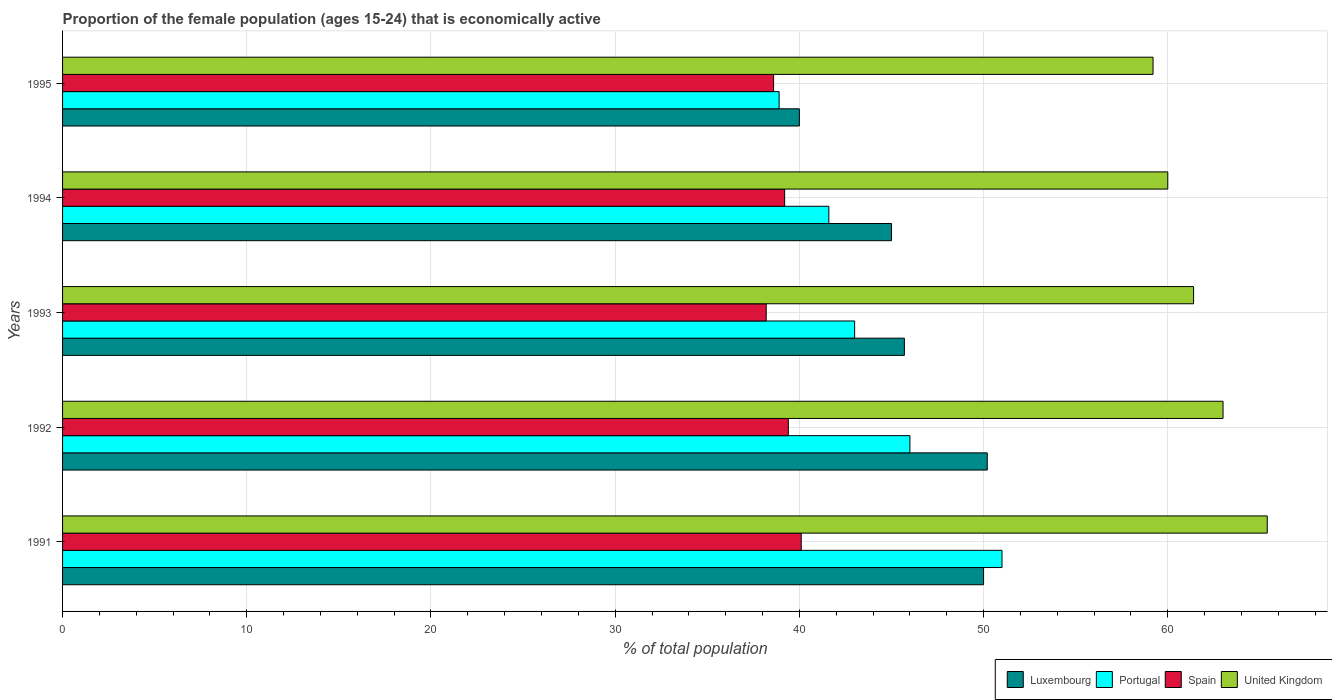How many different coloured bars are there?
Your answer should be very brief. 4. What is the label of the 1st group of bars from the top?
Your answer should be very brief. 1995. In how many cases, is the number of bars for a given year not equal to the number of legend labels?
Provide a short and direct response. 0. Across all years, what is the maximum proportion of the female population that is economically active in United Kingdom?
Your answer should be very brief. 65.4. Across all years, what is the minimum proportion of the female population that is economically active in Portugal?
Ensure brevity in your answer.  38.9. What is the total proportion of the female population that is economically active in Luxembourg in the graph?
Make the answer very short. 230.9. What is the difference between the proportion of the female population that is economically active in United Kingdom in 1991 and that in 1993?
Provide a succinct answer. 4. What is the difference between the proportion of the female population that is economically active in Portugal in 1992 and the proportion of the female population that is economically active in Luxembourg in 1993?
Your answer should be very brief. 0.3. What is the average proportion of the female population that is economically active in Luxembourg per year?
Offer a very short reply. 46.18. In the year 1992, what is the difference between the proportion of the female population that is economically active in Spain and proportion of the female population that is economically active in Portugal?
Your answer should be very brief. -6.6. What is the ratio of the proportion of the female population that is economically active in United Kingdom in 1991 to that in 1993?
Give a very brief answer. 1.07. Is the proportion of the female population that is economically active in Spain in 1991 less than that in 1992?
Your answer should be compact. No. Is the difference between the proportion of the female population that is economically active in Spain in 1991 and 1995 greater than the difference between the proportion of the female population that is economically active in Portugal in 1991 and 1995?
Offer a very short reply. No. What is the difference between the highest and the second highest proportion of the female population that is economically active in Spain?
Make the answer very short. 0.7. What is the difference between the highest and the lowest proportion of the female population that is economically active in Spain?
Give a very brief answer. 1.9. In how many years, is the proportion of the female population that is economically active in Portugal greater than the average proportion of the female population that is economically active in Portugal taken over all years?
Offer a terse response. 2. Is it the case that in every year, the sum of the proportion of the female population that is economically active in Luxembourg and proportion of the female population that is economically active in Spain is greater than the sum of proportion of the female population that is economically active in Portugal and proportion of the female population that is economically active in United Kingdom?
Keep it short and to the point. No. What does the 1st bar from the bottom in 1995 represents?
Offer a very short reply. Luxembourg. Is it the case that in every year, the sum of the proportion of the female population that is economically active in Portugal and proportion of the female population that is economically active in Spain is greater than the proportion of the female population that is economically active in United Kingdom?
Your response must be concise. Yes. How many years are there in the graph?
Offer a very short reply. 5. What is the difference between two consecutive major ticks on the X-axis?
Provide a short and direct response. 10. How many legend labels are there?
Offer a terse response. 4. How are the legend labels stacked?
Keep it short and to the point. Horizontal. What is the title of the graph?
Provide a short and direct response. Proportion of the female population (ages 15-24) that is economically active. Does "Croatia" appear as one of the legend labels in the graph?
Give a very brief answer. No. What is the label or title of the X-axis?
Offer a terse response. % of total population. What is the % of total population of Luxembourg in 1991?
Offer a terse response. 50. What is the % of total population of Portugal in 1991?
Your answer should be very brief. 51. What is the % of total population in Spain in 1991?
Give a very brief answer. 40.1. What is the % of total population of United Kingdom in 1991?
Offer a terse response. 65.4. What is the % of total population in Luxembourg in 1992?
Ensure brevity in your answer.  50.2. What is the % of total population in Portugal in 1992?
Provide a short and direct response. 46. What is the % of total population in Spain in 1992?
Make the answer very short. 39.4. What is the % of total population of United Kingdom in 1992?
Offer a very short reply. 63. What is the % of total population in Luxembourg in 1993?
Ensure brevity in your answer.  45.7. What is the % of total population in Portugal in 1993?
Ensure brevity in your answer.  43. What is the % of total population of Spain in 1993?
Offer a terse response. 38.2. What is the % of total population of United Kingdom in 1993?
Make the answer very short. 61.4. What is the % of total population in Luxembourg in 1994?
Your answer should be very brief. 45. What is the % of total population in Portugal in 1994?
Your response must be concise. 41.6. What is the % of total population of Spain in 1994?
Your answer should be very brief. 39.2. What is the % of total population in Luxembourg in 1995?
Provide a short and direct response. 40. What is the % of total population in Portugal in 1995?
Make the answer very short. 38.9. What is the % of total population in Spain in 1995?
Offer a very short reply. 38.6. What is the % of total population in United Kingdom in 1995?
Give a very brief answer. 59.2. Across all years, what is the maximum % of total population in Luxembourg?
Make the answer very short. 50.2. Across all years, what is the maximum % of total population of Spain?
Keep it short and to the point. 40.1. Across all years, what is the maximum % of total population in United Kingdom?
Your answer should be compact. 65.4. Across all years, what is the minimum % of total population of Portugal?
Offer a terse response. 38.9. Across all years, what is the minimum % of total population of Spain?
Provide a succinct answer. 38.2. Across all years, what is the minimum % of total population of United Kingdom?
Keep it short and to the point. 59.2. What is the total % of total population in Luxembourg in the graph?
Provide a short and direct response. 230.9. What is the total % of total population in Portugal in the graph?
Ensure brevity in your answer.  220.5. What is the total % of total population of Spain in the graph?
Make the answer very short. 195.5. What is the total % of total population in United Kingdom in the graph?
Your response must be concise. 309. What is the difference between the % of total population in Luxembourg in 1991 and that in 1992?
Provide a succinct answer. -0.2. What is the difference between the % of total population in Portugal in 1991 and that in 1992?
Keep it short and to the point. 5. What is the difference between the % of total population in Portugal in 1991 and that in 1993?
Keep it short and to the point. 8. What is the difference between the % of total population of Luxembourg in 1991 and that in 1994?
Your answer should be compact. 5. What is the difference between the % of total population in Portugal in 1991 and that in 1994?
Make the answer very short. 9.4. What is the difference between the % of total population in Spain in 1991 and that in 1994?
Your answer should be compact. 0.9. What is the difference between the % of total population of United Kingdom in 1991 and that in 1994?
Keep it short and to the point. 5.4. What is the difference between the % of total population of United Kingdom in 1991 and that in 1995?
Provide a short and direct response. 6.2. What is the difference between the % of total population in Luxembourg in 1992 and that in 1993?
Provide a short and direct response. 4.5. What is the difference between the % of total population of Portugal in 1992 and that in 1993?
Offer a very short reply. 3. What is the difference between the % of total population in United Kingdom in 1992 and that in 1993?
Your response must be concise. 1.6. What is the difference between the % of total population in Spain in 1992 and that in 1994?
Give a very brief answer. 0.2. What is the difference between the % of total population of Portugal in 1992 and that in 1995?
Give a very brief answer. 7.1. What is the difference between the % of total population in United Kingdom in 1992 and that in 1995?
Provide a succinct answer. 3.8. What is the difference between the % of total population of Portugal in 1993 and that in 1994?
Keep it short and to the point. 1.4. What is the difference between the % of total population of Spain in 1993 and that in 1994?
Offer a very short reply. -1. What is the difference between the % of total population of United Kingdom in 1993 and that in 1994?
Your answer should be compact. 1.4. What is the difference between the % of total population of Luxembourg in 1993 and that in 1995?
Your answer should be compact. 5.7. What is the difference between the % of total population of Spain in 1993 and that in 1995?
Your answer should be compact. -0.4. What is the difference between the % of total population in United Kingdom in 1993 and that in 1995?
Your answer should be compact. 2.2. What is the difference between the % of total population in Luxembourg in 1994 and that in 1995?
Your answer should be very brief. 5. What is the difference between the % of total population in Portugal in 1994 and that in 1995?
Provide a succinct answer. 2.7. What is the difference between the % of total population in Portugal in 1991 and the % of total population in Spain in 1992?
Offer a terse response. 11.6. What is the difference between the % of total population of Spain in 1991 and the % of total population of United Kingdom in 1992?
Your answer should be very brief. -22.9. What is the difference between the % of total population of Luxembourg in 1991 and the % of total population of Portugal in 1993?
Provide a succinct answer. 7. What is the difference between the % of total population of Luxembourg in 1991 and the % of total population of Spain in 1993?
Your answer should be very brief. 11.8. What is the difference between the % of total population in Portugal in 1991 and the % of total population in Spain in 1993?
Keep it short and to the point. 12.8. What is the difference between the % of total population in Spain in 1991 and the % of total population in United Kingdom in 1993?
Provide a succinct answer. -21.3. What is the difference between the % of total population in Luxembourg in 1991 and the % of total population in Portugal in 1994?
Keep it short and to the point. 8.4. What is the difference between the % of total population of Luxembourg in 1991 and the % of total population of Spain in 1994?
Your answer should be very brief. 10.8. What is the difference between the % of total population in Luxembourg in 1991 and the % of total population in United Kingdom in 1994?
Your answer should be compact. -10. What is the difference between the % of total population of Portugal in 1991 and the % of total population of Spain in 1994?
Your answer should be very brief. 11.8. What is the difference between the % of total population in Spain in 1991 and the % of total population in United Kingdom in 1994?
Provide a succinct answer. -19.9. What is the difference between the % of total population of Luxembourg in 1991 and the % of total population of Spain in 1995?
Ensure brevity in your answer.  11.4. What is the difference between the % of total population of Portugal in 1991 and the % of total population of Spain in 1995?
Your response must be concise. 12.4. What is the difference between the % of total population in Spain in 1991 and the % of total population in United Kingdom in 1995?
Offer a very short reply. -19.1. What is the difference between the % of total population in Luxembourg in 1992 and the % of total population in Spain in 1993?
Offer a terse response. 12. What is the difference between the % of total population of Luxembourg in 1992 and the % of total population of United Kingdom in 1993?
Offer a terse response. -11.2. What is the difference between the % of total population of Portugal in 1992 and the % of total population of Spain in 1993?
Keep it short and to the point. 7.8. What is the difference between the % of total population of Portugal in 1992 and the % of total population of United Kingdom in 1993?
Your answer should be compact. -15.4. What is the difference between the % of total population of Luxembourg in 1992 and the % of total population of Spain in 1994?
Your answer should be compact. 11. What is the difference between the % of total population in Portugal in 1992 and the % of total population in Spain in 1994?
Provide a short and direct response. 6.8. What is the difference between the % of total population of Portugal in 1992 and the % of total population of United Kingdom in 1994?
Provide a succinct answer. -14. What is the difference between the % of total population in Spain in 1992 and the % of total population in United Kingdom in 1994?
Provide a short and direct response. -20.6. What is the difference between the % of total population of Luxembourg in 1992 and the % of total population of United Kingdom in 1995?
Ensure brevity in your answer.  -9. What is the difference between the % of total population in Portugal in 1992 and the % of total population in Spain in 1995?
Give a very brief answer. 7.4. What is the difference between the % of total population of Spain in 1992 and the % of total population of United Kingdom in 1995?
Ensure brevity in your answer.  -19.8. What is the difference between the % of total population of Luxembourg in 1993 and the % of total population of Spain in 1994?
Provide a short and direct response. 6.5. What is the difference between the % of total population of Luxembourg in 1993 and the % of total population of United Kingdom in 1994?
Provide a short and direct response. -14.3. What is the difference between the % of total population of Spain in 1993 and the % of total population of United Kingdom in 1994?
Keep it short and to the point. -21.8. What is the difference between the % of total population in Luxembourg in 1993 and the % of total population in Spain in 1995?
Provide a short and direct response. 7.1. What is the difference between the % of total population in Luxembourg in 1993 and the % of total population in United Kingdom in 1995?
Provide a short and direct response. -13.5. What is the difference between the % of total population of Portugal in 1993 and the % of total population of Spain in 1995?
Keep it short and to the point. 4.4. What is the difference between the % of total population in Portugal in 1993 and the % of total population in United Kingdom in 1995?
Your answer should be compact. -16.2. What is the difference between the % of total population in Spain in 1993 and the % of total population in United Kingdom in 1995?
Provide a succinct answer. -21. What is the difference between the % of total population in Luxembourg in 1994 and the % of total population in Portugal in 1995?
Give a very brief answer. 6.1. What is the difference between the % of total population in Portugal in 1994 and the % of total population in Spain in 1995?
Make the answer very short. 3. What is the difference between the % of total population of Portugal in 1994 and the % of total population of United Kingdom in 1995?
Offer a terse response. -17.6. What is the average % of total population in Luxembourg per year?
Your answer should be very brief. 46.18. What is the average % of total population in Portugal per year?
Provide a short and direct response. 44.1. What is the average % of total population in Spain per year?
Make the answer very short. 39.1. What is the average % of total population of United Kingdom per year?
Make the answer very short. 61.8. In the year 1991, what is the difference between the % of total population of Luxembourg and % of total population of Portugal?
Your answer should be compact. -1. In the year 1991, what is the difference between the % of total population of Luxembourg and % of total population of United Kingdom?
Your answer should be very brief. -15.4. In the year 1991, what is the difference between the % of total population in Portugal and % of total population in United Kingdom?
Provide a succinct answer. -14.4. In the year 1991, what is the difference between the % of total population in Spain and % of total population in United Kingdom?
Your answer should be very brief. -25.3. In the year 1992, what is the difference between the % of total population of Luxembourg and % of total population of Spain?
Give a very brief answer. 10.8. In the year 1992, what is the difference between the % of total population in Portugal and % of total population in Spain?
Offer a terse response. 6.6. In the year 1992, what is the difference between the % of total population in Portugal and % of total population in United Kingdom?
Offer a terse response. -17. In the year 1992, what is the difference between the % of total population in Spain and % of total population in United Kingdom?
Your response must be concise. -23.6. In the year 1993, what is the difference between the % of total population of Luxembourg and % of total population of Portugal?
Provide a succinct answer. 2.7. In the year 1993, what is the difference between the % of total population of Luxembourg and % of total population of United Kingdom?
Provide a succinct answer. -15.7. In the year 1993, what is the difference between the % of total population in Portugal and % of total population in Spain?
Your response must be concise. 4.8. In the year 1993, what is the difference between the % of total population of Portugal and % of total population of United Kingdom?
Make the answer very short. -18.4. In the year 1993, what is the difference between the % of total population of Spain and % of total population of United Kingdom?
Provide a short and direct response. -23.2. In the year 1994, what is the difference between the % of total population of Luxembourg and % of total population of Portugal?
Provide a short and direct response. 3.4. In the year 1994, what is the difference between the % of total population in Luxembourg and % of total population in Spain?
Your answer should be very brief. 5.8. In the year 1994, what is the difference between the % of total population of Luxembourg and % of total population of United Kingdom?
Provide a succinct answer. -15. In the year 1994, what is the difference between the % of total population of Portugal and % of total population of Spain?
Give a very brief answer. 2.4. In the year 1994, what is the difference between the % of total population of Portugal and % of total population of United Kingdom?
Your response must be concise. -18.4. In the year 1994, what is the difference between the % of total population in Spain and % of total population in United Kingdom?
Provide a succinct answer. -20.8. In the year 1995, what is the difference between the % of total population in Luxembourg and % of total population in Spain?
Offer a very short reply. 1.4. In the year 1995, what is the difference between the % of total population of Luxembourg and % of total population of United Kingdom?
Offer a very short reply. -19.2. In the year 1995, what is the difference between the % of total population of Portugal and % of total population of United Kingdom?
Your answer should be very brief. -20.3. In the year 1995, what is the difference between the % of total population in Spain and % of total population in United Kingdom?
Your response must be concise. -20.6. What is the ratio of the % of total population in Luxembourg in 1991 to that in 1992?
Ensure brevity in your answer.  1. What is the ratio of the % of total population in Portugal in 1991 to that in 1992?
Offer a terse response. 1.11. What is the ratio of the % of total population in Spain in 1991 to that in 1992?
Make the answer very short. 1.02. What is the ratio of the % of total population of United Kingdom in 1991 to that in 1992?
Offer a terse response. 1.04. What is the ratio of the % of total population of Luxembourg in 1991 to that in 1993?
Offer a very short reply. 1.09. What is the ratio of the % of total population in Portugal in 1991 to that in 1993?
Your answer should be very brief. 1.19. What is the ratio of the % of total population in Spain in 1991 to that in 1993?
Make the answer very short. 1.05. What is the ratio of the % of total population in United Kingdom in 1991 to that in 1993?
Provide a succinct answer. 1.07. What is the ratio of the % of total population of Portugal in 1991 to that in 1994?
Your answer should be very brief. 1.23. What is the ratio of the % of total population in United Kingdom in 1991 to that in 1994?
Offer a terse response. 1.09. What is the ratio of the % of total population of Portugal in 1991 to that in 1995?
Your response must be concise. 1.31. What is the ratio of the % of total population in Spain in 1991 to that in 1995?
Your answer should be very brief. 1.04. What is the ratio of the % of total population in United Kingdom in 1991 to that in 1995?
Make the answer very short. 1.1. What is the ratio of the % of total population in Luxembourg in 1992 to that in 1993?
Your answer should be compact. 1.1. What is the ratio of the % of total population of Portugal in 1992 to that in 1993?
Provide a short and direct response. 1.07. What is the ratio of the % of total population of Spain in 1992 to that in 1993?
Make the answer very short. 1.03. What is the ratio of the % of total population in United Kingdom in 1992 to that in 1993?
Provide a short and direct response. 1.03. What is the ratio of the % of total population in Luxembourg in 1992 to that in 1994?
Your response must be concise. 1.12. What is the ratio of the % of total population of Portugal in 1992 to that in 1994?
Ensure brevity in your answer.  1.11. What is the ratio of the % of total population of United Kingdom in 1992 to that in 1994?
Ensure brevity in your answer.  1.05. What is the ratio of the % of total population of Luxembourg in 1992 to that in 1995?
Provide a succinct answer. 1.25. What is the ratio of the % of total population of Portugal in 1992 to that in 1995?
Ensure brevity in your answer.  1.18. What is the ratio of the % of total population of Spain in 1992 to that in 1995?
Offer a terse response. 1.02. What is the ratio of the % of total population in United Kingdom in 1992 to that in 1995?
Your answer should be very brief. 1.06. What is the ratio of the % of total population of Luxembourg in 1993 to that in 1994?
Ensure brevity in your answer.  1.02. What is the ratio of the % of total population in Portugal in 1993 to that in 1994?
Offer a very short reply. 1.03. What is the ratio of the % of total population of Spain in 1993 to that in 1994?
Your answer should be very brief. 0.97. What is the ratio of the % of total population in United Kingdom in 1993 to that in 1994?
Offer a very short reply. 1.02. What is the ratio of the % of total population of Luxembourg in 1993 to that in 1995?
Your response must be concise. 1.14. What is the ratio of the % of total population in Portugal in 1993 to that in 1995?
Make the answer very short. 1.11. What is the ratio of the % of total population in United Kingdom in 1993 to that in 1995?
Provide a succinct answer. 1.04. What is the ratio of the % of total population in Luxembourg in 1994 to that in 1995?
Keep it short and to the point. 1.12. What is the ratio of the % of total population of Portugal in 1994 to that in 1995?
Your answer should be compact. 1.07. What is the ratio of the % of total population of Spain in 1994 to that in 1995?
Your response must be concise. 1.02. What is the ratio of the % of total population in United Kingdom in 1994 to that in 1995?
Keep it short and to the point. 1.01. What is the difference between the highest and the second highest % of total population in Luxembourg?
Your answer should be very brief. 0.2. What is the difference between the highest and the second highest % of total population of United Kingdom?
Ensure brevity in your answer.  2.4. What is the difference between the highest and the lowest % of total population in Luxembourg?
Offer a very short reply. 10.2. What is the difference between the highest and the lowest % of total population of Portugal?
Ensure brevity in your answer.  12.1. What is the difference between the highest and the lowest % of total population of United Kingdom?
Your response must be concise. 6.2. 